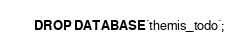Convert code to text. <code><loc_0><loc_0><loc_500><loc_500><_SQL_>DROP DATABASE `themis_todo`;</code> 